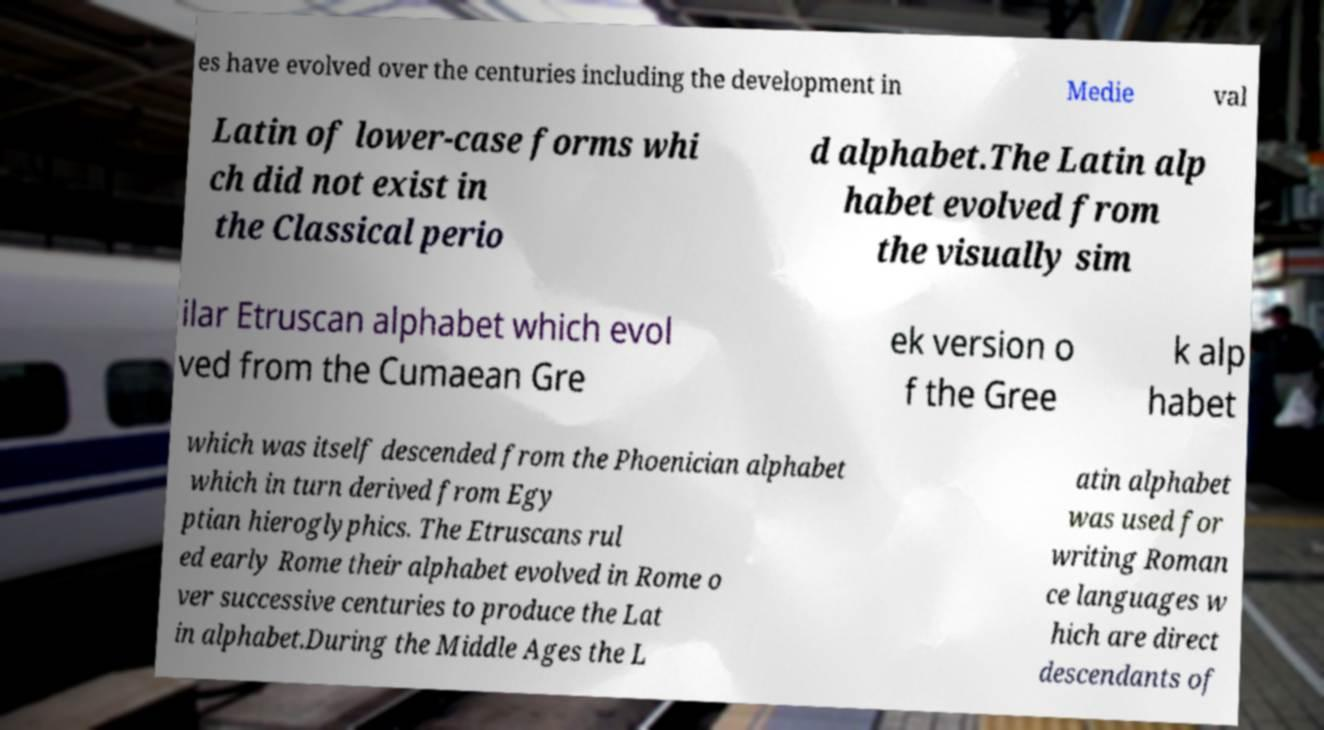For documentation purposes, I need the text within this image transcribed. Could you provide that? es have evolved over the centuries including the development in Medie val Latin of lower-case forms whi ch did not exist in the Classical perio d alphabet.The Latin alp habet evolved from the visually sim ilar Etruscan alphabet which evol ved from the Cumaean Gre ek version o f the Gree k alp habet which was itself descended from the Phoenician alphabet which in turn derived from Egy ptian hieroglyphics. The Etruscans rul ed early Rome their alphabet evolved in Rome o ver successive centuries to produce the Lat in alphabet.During the Middle Ages the L atin alphabet was used for writing Roman ce languages w hich are direct descendants of 